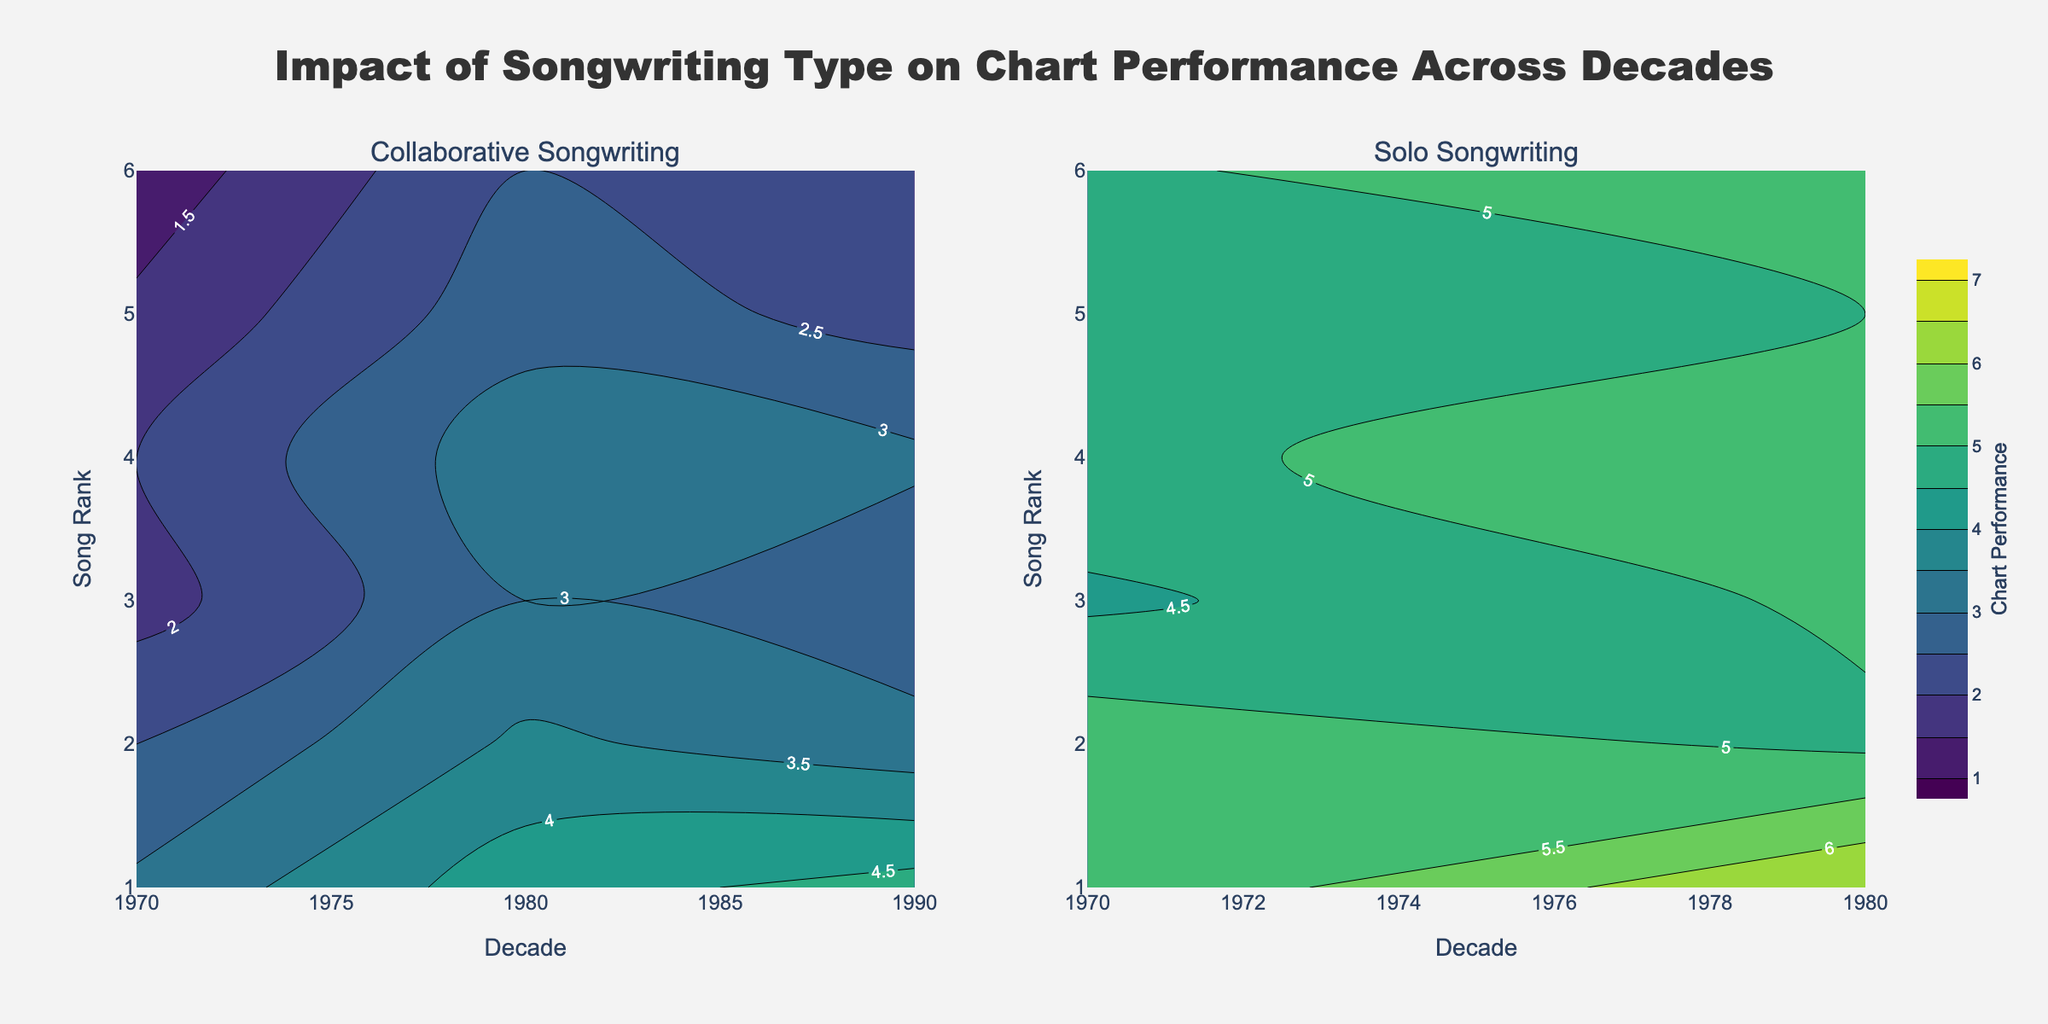What is the title of the figure? The title is clearly displayed at the top of the figure.
Answer: Impact of Songwriting Type on Chart Performance Across Decades How many subplots are there in the figure? There are two distinct areas within the plot, each representing a different aspect of the data.
Answer: Two What are the labels for the subplots? The labels are given at the top of each subplot.
Answer: Collaborative Songwriting, Solo Songwriting What are the x-axis titles? The x-axis titles are displayed below the x-axis in both subplots.
Answer: Decade What are the y-axis titles? The y-axis titles are displayed next to the y-axis in both subplots.
Answer: Song Rank During which decade did collaborative songwriting achieve the best average chart performance? The data shows darker colors (indicating better performance) in the 2020s for collaborative songwriting.
Answer: 2020 How does the chart performance of solo songwriting in the 1980s compare to the 1990s? By observing the color and contour labels, solo songwriting in the 1980s had generally worse performance compared to the 1990s.
Answer: Worse in the 1980s Are there any decades where solo songwriting consistently reached a lower rank (higher performance) than collaborative songwriting? Comparing both subplots visually, solo songwriting consistently reaches better chart ranks in the 2020s.
Answer: 2020 Which subplot has a wider distribution of performance values within each decade? By observing the contour labels, the subplot for solo songwriting has a wider range of chart performance values.
Answer: Solo Songwriting In what decade does the chart performance for collaborative songwriting show the most improvement compared to the previous decade? Observing the trend of contour lines, the biggest improvement is seen from the 2010s to the 2020s.
Answer: From 2010 to 2020 